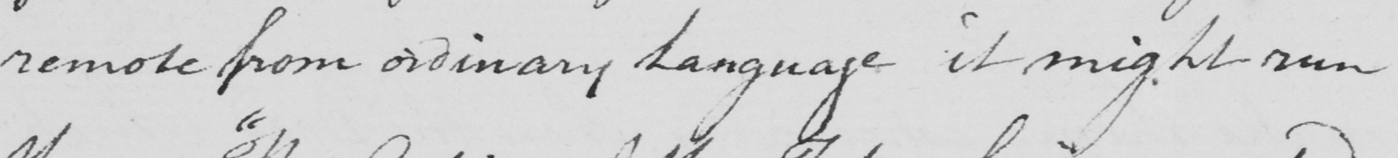Transcribe the text shown in this historical manuscript line. remote from ordinary Language it might run 